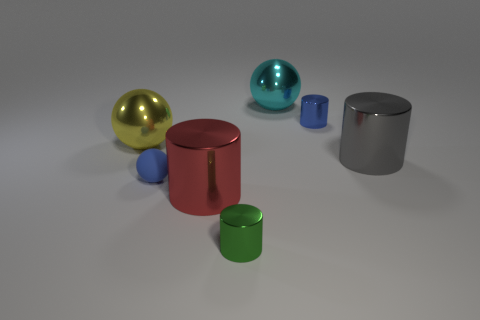Is there anything else that is made of the same material as the tiny sphere?
Provide a short and direct response. No. Are the small object behind the tiny blue ball and the blue sphere made of the same material?
Your answer should be very brief. No. What is the color of the large metallic object that is on the left side of the tiny green thing and to the right of the yellow metallic sphere?
Give a very brief answer. Red. There is a large metallic sphere on the right side of the green metal cylinder; how many cyan shiny spheres are behind it?
Ensure brevity in your answer.  0. What material is the yellow thing that is the same shape as the big cyan metallic thing?
Provide a succinct answer. Metal. What color is the matte thing?
Your response must be concise. Blue. How many objects are either big cyan shiny balls or rubber objects?
Your answer should be compact. 2. The tiny metallic object in front of the tiny blue rubber sphere that is on the left side of the cyan sphere is what shape?
Ensure brevity in your answer.  Cylinder. What number of other objects are the same material as the big yellow sphere?
Keep it short and to the point. 5. Are the large red thing and the tiny blue thing behind the big yellow ball made of the same material?
Your answer should be compact. Yes. 